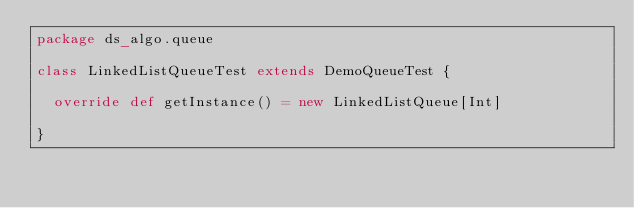<code> <loc_0><loc_0><loc_500><loc_500><_Scala_>package ds_algo.queue

class LinkedListQueueTest extends DemoQueueTest {

  override def getInstance() = new LinkedListQueue[Int]

}
</code> 